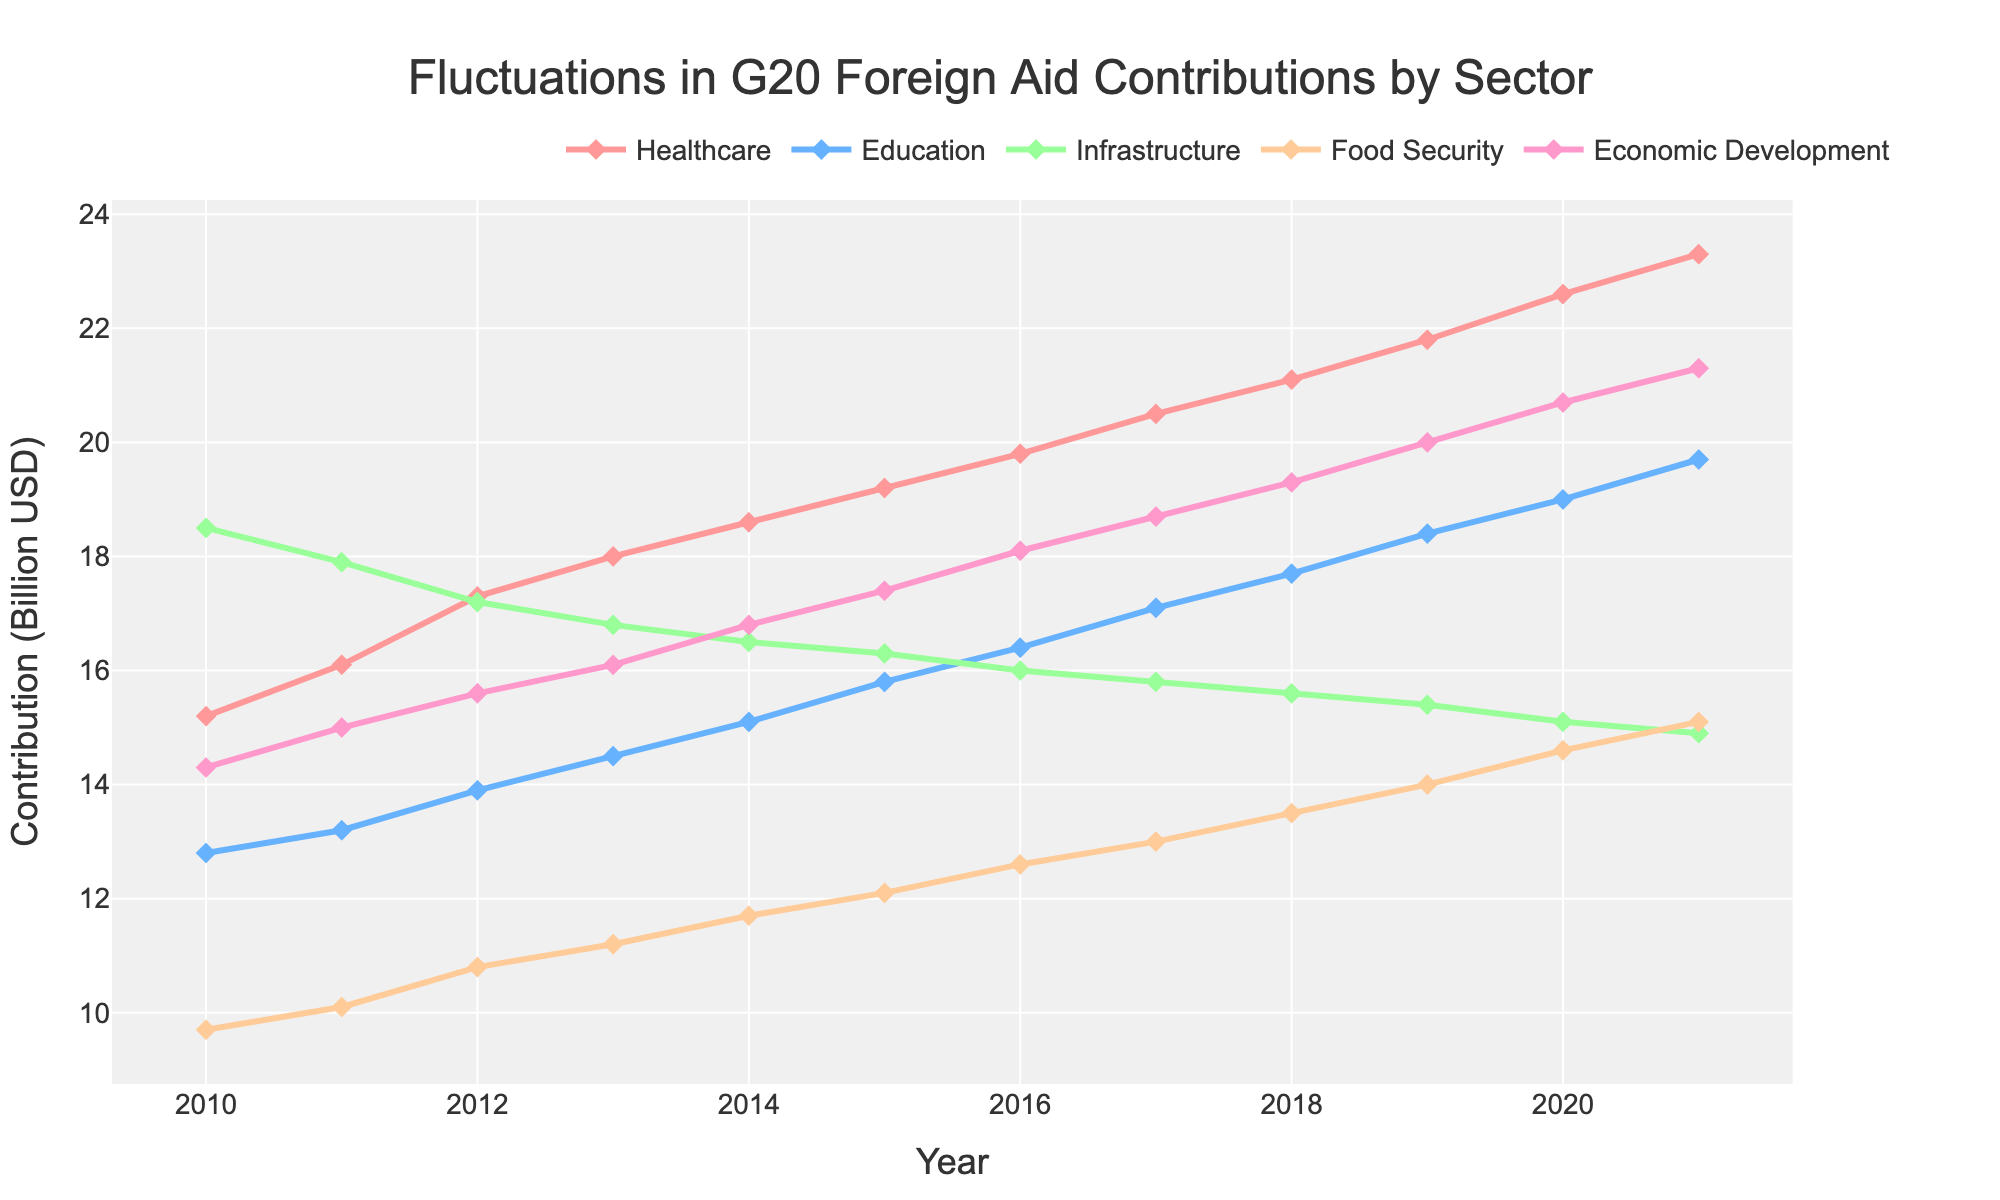Which year witnessed the highest contribution to Healthcare? To determine the highest contribution to Healthcare, we should look at the line corresponding to Healthcare and identify the peak point. The peak is in 2021 with a value of 23.3 billion USD.
Answer: 2021 In 2016, were the contributions to Education higher or lower than those to Infrastructure? We need to compare the values for Education and Infrastructure in 2016. The Education contribution was 16.4 billion USD, whereas Infrastructure was 16.0 billion USD. Therefore, Education was higher.
Answer: Higher By how much did contributions to Food Security increase from 2010 to 2021? We need to find the difference in contributions for Food Security between 2010 and 2021. The values are 15.1 billion USD (2021) and 9.7 billion USD (2010). The increase is 15.1 - 9.7 = 5.4 billion USD.
Answer: 5.4 billion USD What is the average contribution to Economic Development over the given years? Calculate the average by summing up all the contributions from 2010 to 2021 and dividing by the number of years. (14.3 + 15.0 + 15.6 + 16.1 + 16.8 + 17.4 + 18.1 + 18.7 + 19.3 + 20.0 + 20.7 + 21.3) / 12 = 204.3 / 12 ≈ 17.025 billion USD.
Answer: ≈ 17.025 billion USD What pattern can be observed from the Healthcare contributions over the years from 2010 to 2021? Look at the Healthcare line and observe the trend. The contributions show a consistent upward trend, increasing each year from 15.2 billion USD in 2010 to 23.3 billion USD in 2021.
Answer: Consistent upward trend Which sector had the smallest contribution in 2021, and what was the value? We should look at the values for all sectors in 2021 and identify the smallest one. Infrastructure had the smallest contribution with 14.9 billion USD.
Answer: Infrastructure, 14.9 billion USD Between which consecutive years did the Education sector see the highest increase in contributions, and what was the increase? Calculate the differences between consecutive years for Education and find the maximum. The highest increase was from 2010 to 2011, which is 13.2 - 12.8 = 0.4 billion USD.
Answer: 2010 to 2011, 0.4 billion USD What is the visual difference between the contribution trends for Infrastructure and Food Security from 2010 to 2021? Infra-structure line generally decreases, whereas Food Security line increases. Infrastructure starts at 18.5 billion USD and declines to 14.9 billion USD, while Food Security increases from 9.7 billion USD to 15.1 billion USD.
Answer: Infrastructure decreases, Food Security increases Which sector had the most consistent (least fluctuating) trend throughout the years, and how can you tell? Visually, the sector with the least fluctuations would have the smoothest line without significant dips or spikes. Economic Development shows a steady rise from 14.3 billion USD in 2010 to 21.3 billion USD in 2021, indicating the most consistent trend.
Answer: Economic Development, consistent steady rise How many years did it take for Economic Development contributions to surpass 20 billion USD? Economic Development contribution exceeded 20 billion USD in 2019. From 2010 to 2019, it took 10 years.
Answer: 10 years 